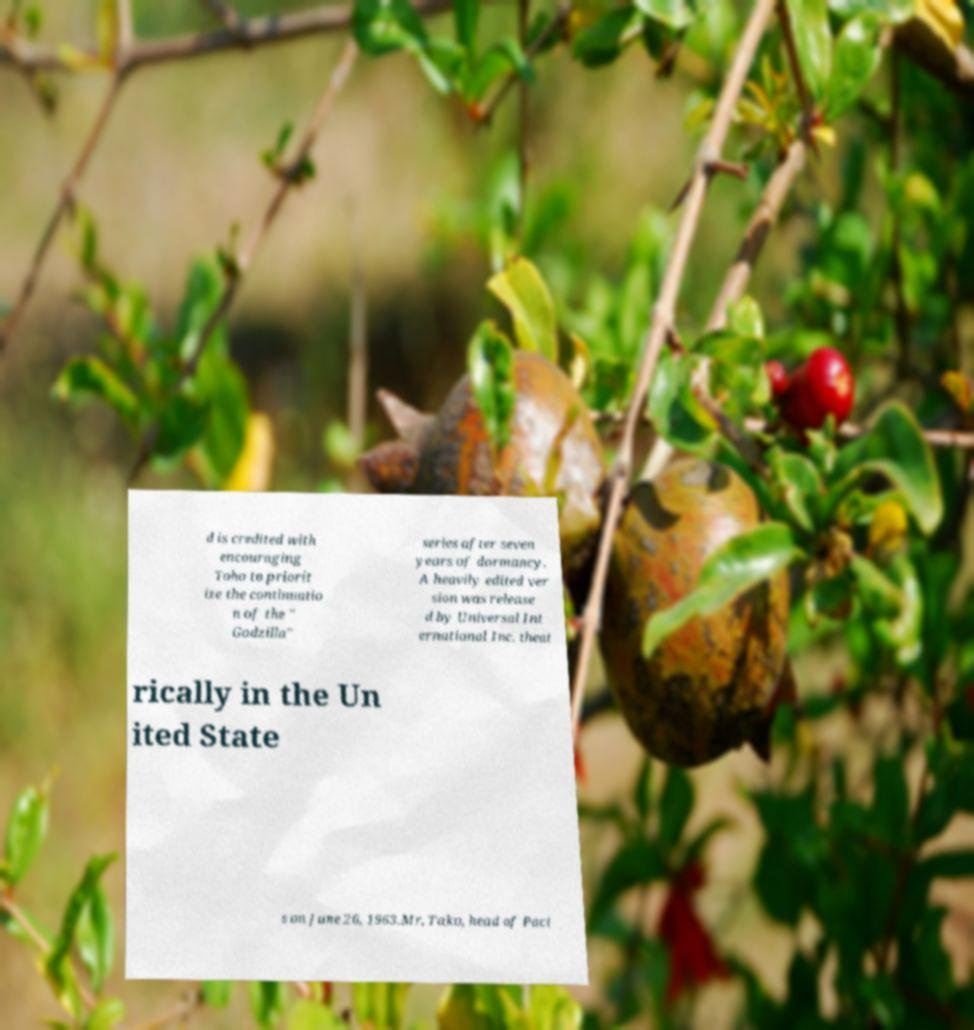Please read and relay the text visible in this image. What does it say? d is credited with encouraging Toho to priorit ize the continuatio n of the " Godzilla" series after seven years of dormancy. A heavily edited ver sion was release d by Universal Int ernational Inc. theat rically in the Un ited State s on June 26, 1963.Mr. Tako, head of Paci 